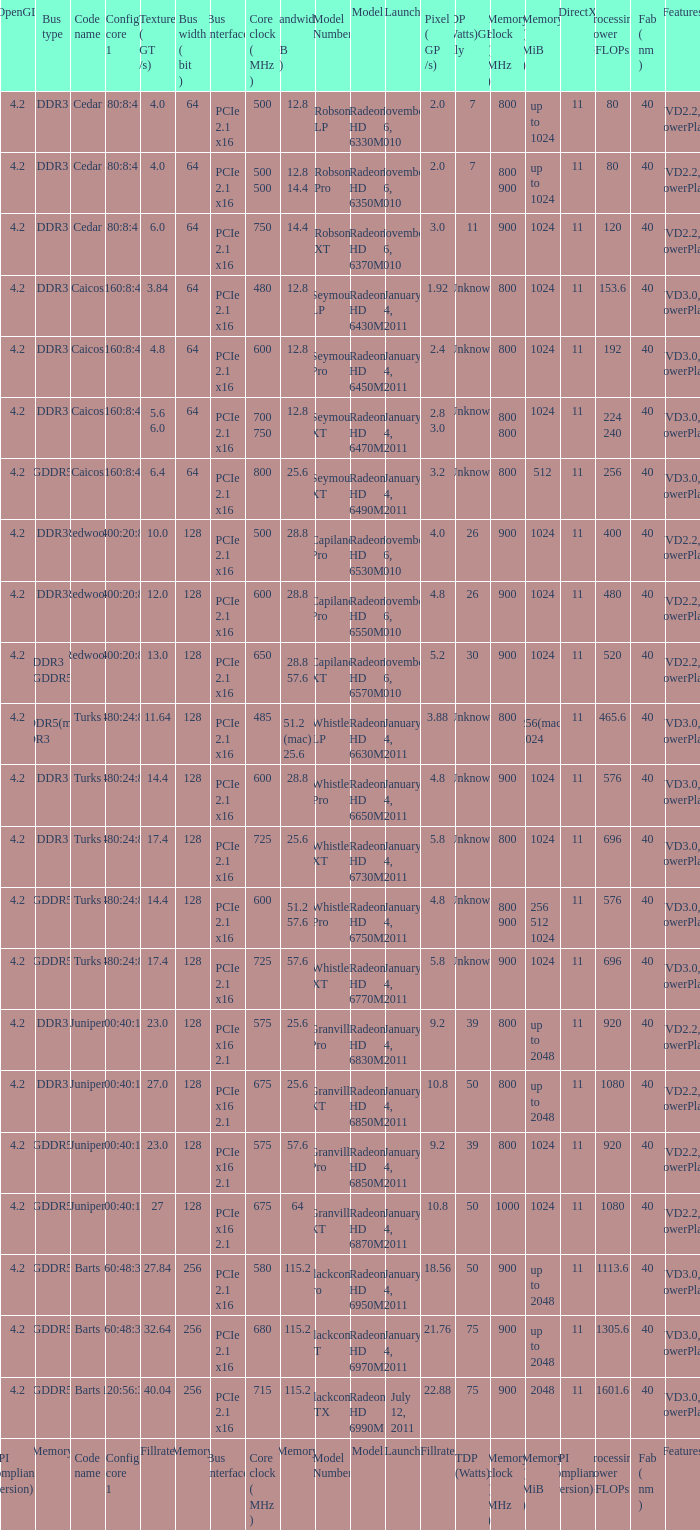What is every bus type for the texture of fillrate? Memory. 